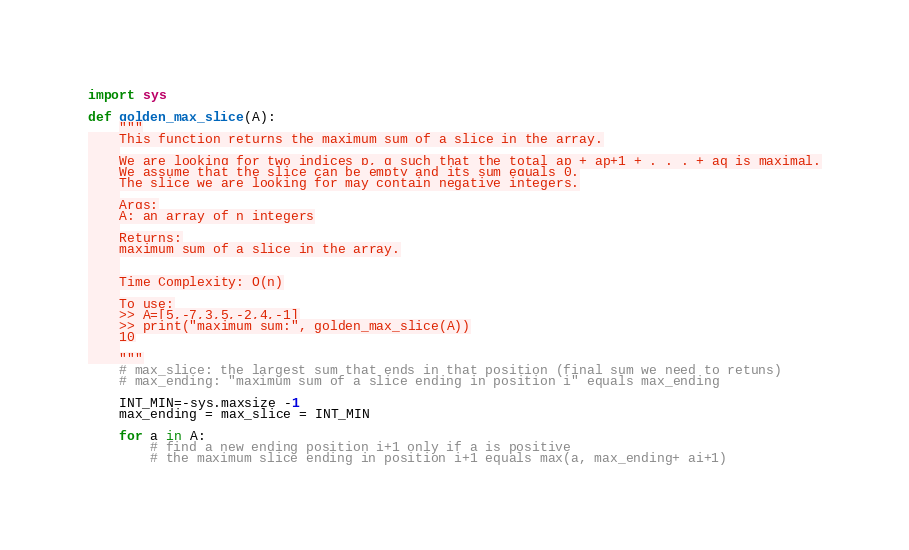<code> <loc_0><loc_0><loc_500><loc_500><_Python_>import sys

def golden_max_slice(A):
    """
    This function returns the maximum sum of a slice in the array.
    
    We are looking for two indices p, q such that the total ap + ap+1 + . . . + aq is maximal.
    We assume that the slice can be empty and its sum equals 0.
    The slice we are looking for may contain negative integers.
    
    Args:
    A: an array of n integers
    
    Returns:
    maximum sum of a slice in the array.
    
    
    Time Complexity: O(n)
    
    To use:
    >> A=[5,-7,3,5,-2,4,-1]
    >> print("maximum sum:", golden_max_slice(A))
    10
    
    """
    # max_slice: the largest sum that ends in that position (final sum we need to retuns)
    # max_ending: "maximum sum of a slice ending in position i" equals max_ending

    INT_MIN=-sys.maxsize -1
    max_ending = max_slice = INT_MIN
    
    for a in A:
        # find a new ending position i+1 only if a is positive
        # the maximum slice ending in position i+1 equals max(a, max_ending+ ai+1)</code> 